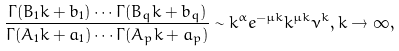<formula> <loc_0><loc_0><loc_500><loc_500>\frac { \Gamma ( B _ { 1 } k + b _ { 1 } ) \cdots \Gamma ( B _ { q } k + b _ { q } ) } { \Gamma ( A _ { 1 } k + a _ { 1 } ) \cdots \Gamma ( A _ { p } k + a _ { p } ) } \sim k ^ { \alpha } e ^ { - \mu { k } } k ^ { \mu { k } } \nu ^ { k } , k \to \infty ,</formula> 